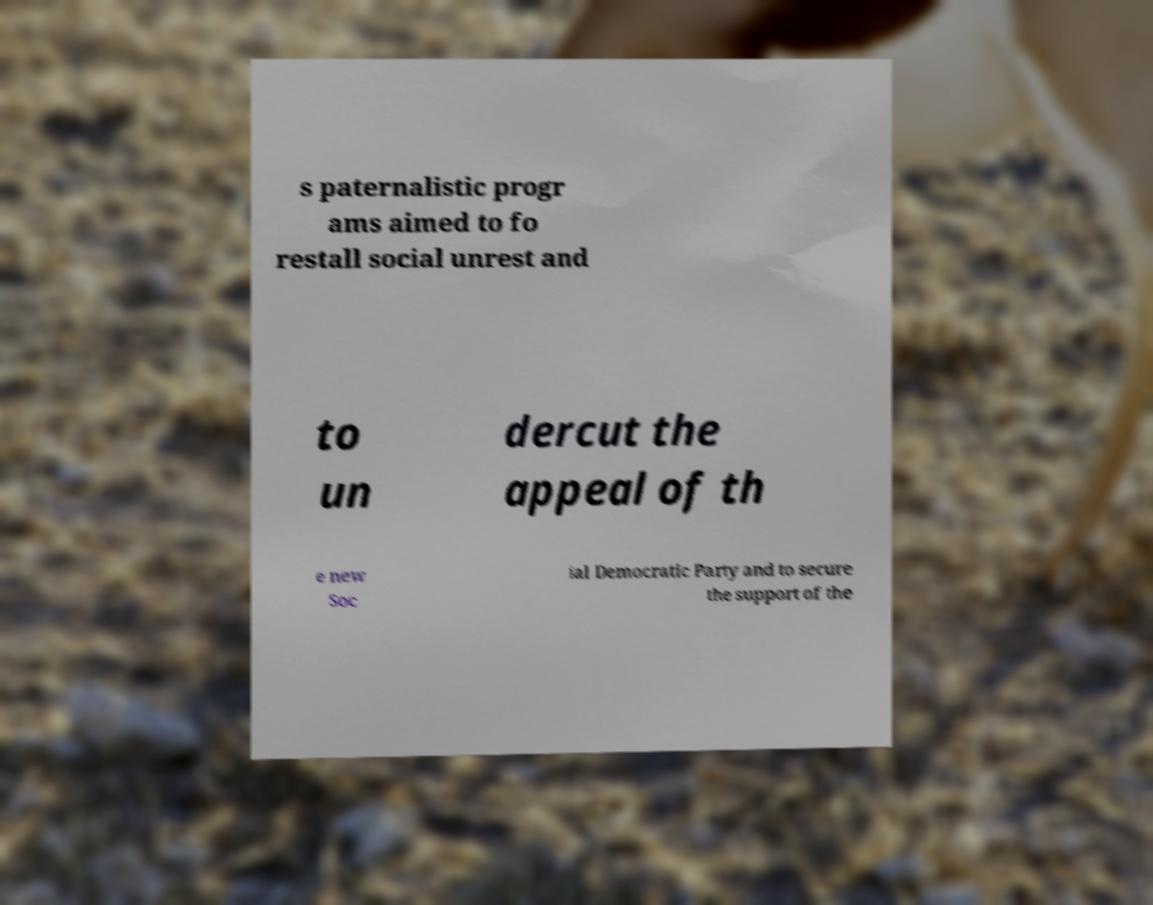For documentation purposes, I need the text within this image transcribed. Could you provide that? s paternalistic progr ams aimed to fo restall social unrest and to un dercut the appeal of th e new Soc ial Democratic Party and to secure the support of the 